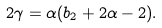Convert formula to latex. <formula><loc_0><loc_0><loc_500><loc_500>2 \gamma = \alpha ( b _ { 2 } + 2 \alpha - 2 ) .</formula> 